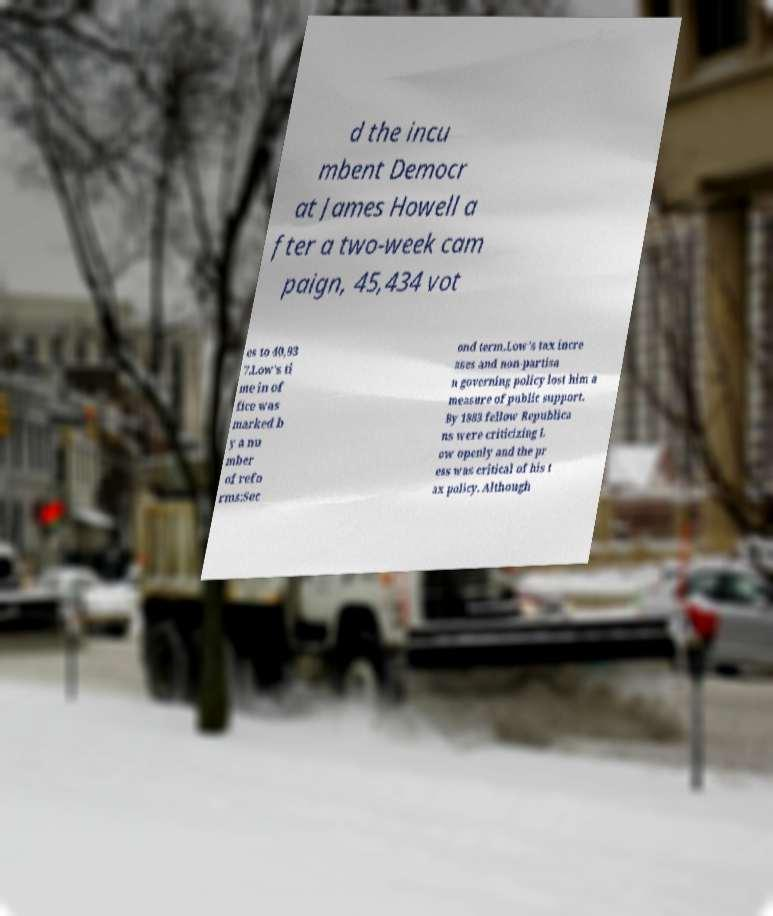There's text embedded in this image that I need extracted. Can you transcribe it verbatim? d the incu mbent Democr at James Howell a fter a two-week cam paign, 45,434 vot es to 40,93 7.Low's ti me in of fice was marked b y a nu mber of refo rms:Sec ond term.Low's tax incre ases and non-partisa n governing policy lost him a measure of public support. By 1883 fellow Republica ns were criticizing L ow openly and the pr ess was critical of his t ax policy. Although 